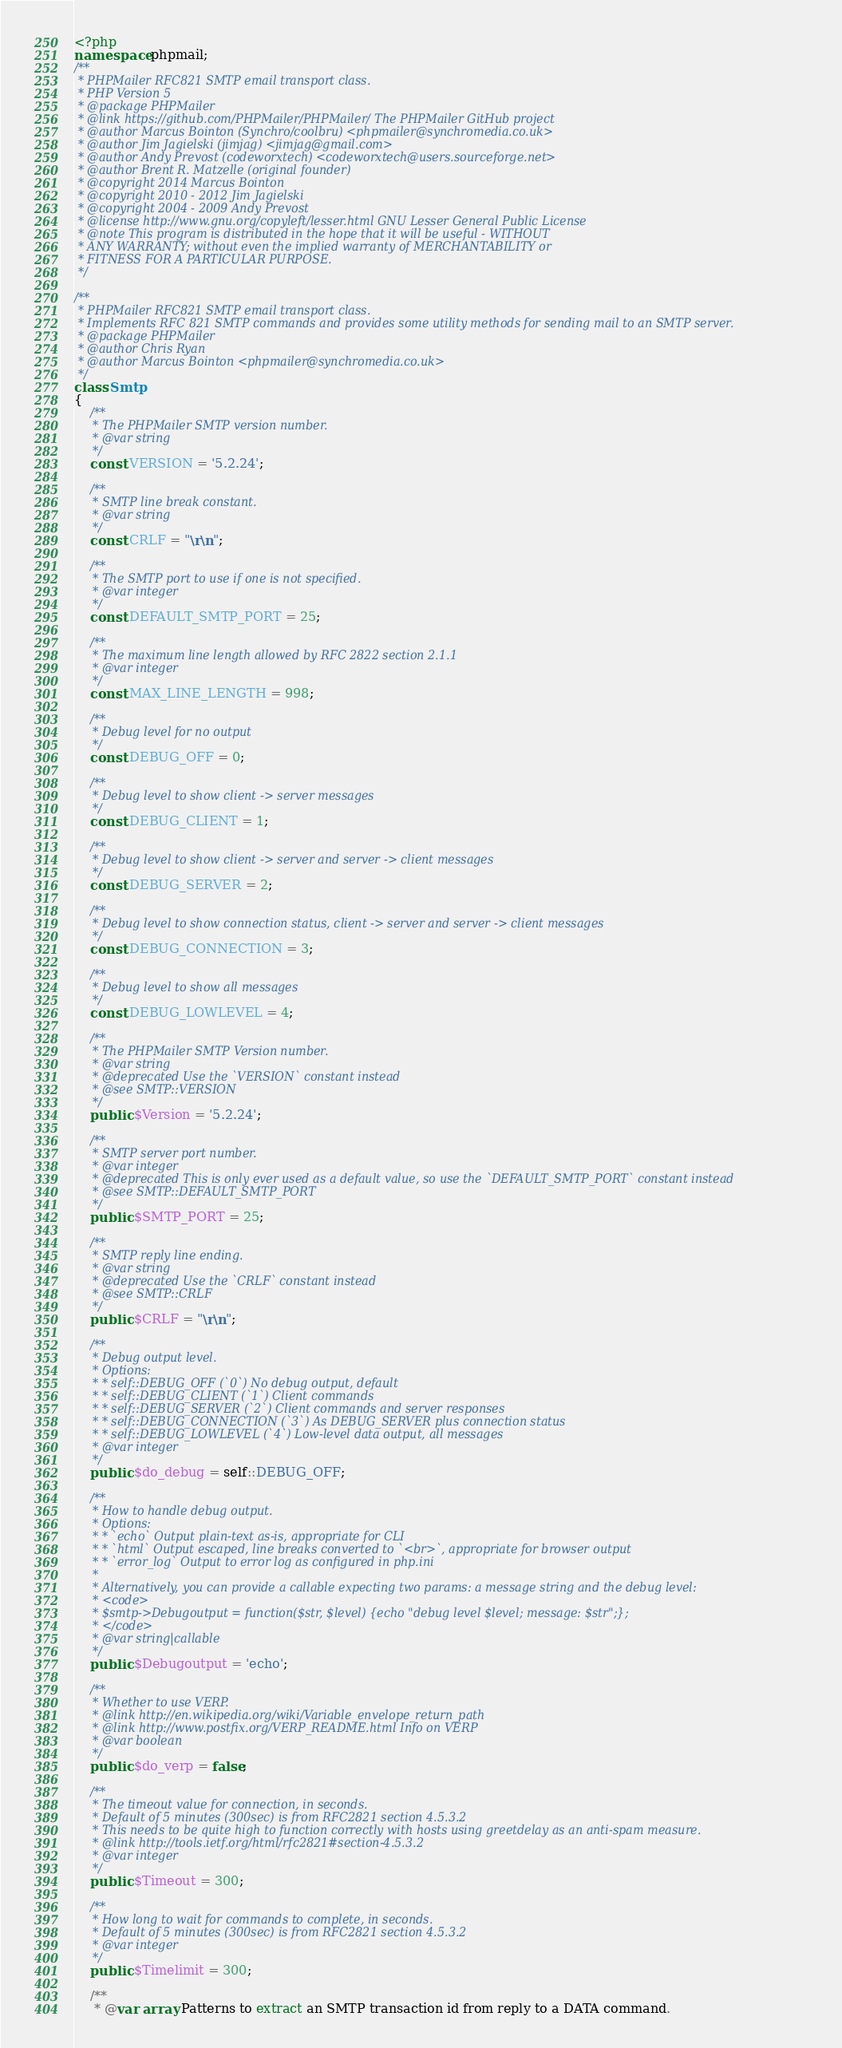Convert code to text. <code><loc_0><loc_0><loc_500><loc_500><_PHP_><?php
namespace phpmail;
/**
 * PHPMailer RFC821 SMTP email transport class.
 * PHP Version 5
 * @package PHPMailer
 * @link https://github.com/PHPMailer/PHPMailer/ The PHPMailer GitHub project
 * @author Marcus Bointon (Synchro/coolbru) <phpmailer@synchromedia.co.uk>
 * @author Jim Jagielski (jimjag) <jimjag@gmail.com>
 * @author Andy Prevost (codeworxtech) <codeworxtech@users.sourceforge.net>
 * @author Brent R. Matzelle (original founder)
 * @copyright 2014 Marcus Bointon
 * @copyright 2010 - 2012 Jim Jagielski
 * @copyright 2004 - 2009 Andy Prevost
 * @license http://www.gnu.org/copyleft/lesser.html GNU Lesser General Public License
 * @note This program is distributed in the hope that it will be useful - WITHOUT
 * ANY WARRANTY; without even the implied warranty of MERCHANTABILITY or
 * FITNESS FOR A PARTICULAR PURPOSE.
 */

/**
 * PHPMailer RFC821 SMTP email transport class.
 * Implements RFC 821 SMTP commands and provides some utility methods for sending mail to an SMTP server.
 * @package PHPMailer
 * @author Chris Ryan
 * @author Marcus Bointon <phpmailer@synchromedia.co.uk>
 */
class Smtp
{
    /**
     * The PHPMailer SMTP version number.
     * @var string
     */
    const VERSION = '5.2.24';

    /**
     * SMTP line break constant.
     * @var string
     */
    const CRLF = "\r\n";

    /**
     * The SMTP port to use if one is not specified.
     * @var integer
     */
    const DEFAULT_SMTP_PORT = 25;

    /**
     * The maximum line length allowed by RFC 2822 section 2.1.1
     * @var integer
     */
    const MAX_LINE_LENGTH = 998;

    /**
     * Debug level for no output
     */
    const DEBUG_OFF = 0;

    /**
     * Debug level to show client -> server messages
     */
    const DEBUG_CLIENT = 1;

    /**
     * Debug level to show client -> server and server -> client messages
     */
    const DEBUG_SERVER = 2;

    /**
     * Debug level to show connection status, client -> server and server -> client messages
     */
    const DEBUG_CONNECTION = 3;

    /**
     * Debug level to show all messages
     */
    const DEBUG_LOWLEVEL = 4;

    /**
     * The PHPMailer SMTP Version number.
     * @var string
     * @deprecated Use the `VERSION` constant instead
     * @see SMTP::VERSION
     */
    public $Version = '5.2.24';

    /**
     * SMTP server port number.
     * @var integer
     * @deprecated This is only ever used as a default value, so use the `DEFAULT_SMTP_PORT` constant instead
     * @see SMTP::DEFAULT_SMTP_PORT
     */
    public $SMTP_PORT = 25;

    /**
     * SMTP reply line ending.
     * @var string
     * @deprecated Use the `CRLF` constant instead
     * @see SMTP::CRLF
     */
    public $CRLF = "\r\n";

    /**
     * Debug output level.
     * Options:
     * * self::DEBUG_OFF (`0`) No debug output, default
     * * self::DEBUG_CLIENT (`1`) Client commands
     * * self::DEBUG_SERVER (`2`) Client commands and server responses
     * * self::DEBUG_CONNECTION (`3`) As DEBUG_SERVER plus connection status
     * * self::DEBUG_LOWLEVEL (`4`) Low-level data output, all messages
     * @var integer
     */
    public $do_debug = self::DEBUG_OFF;

    /**
     * How to handle debug output.
     * Options:
     * * `echo` Output plain-text as-is, appropriate for CLI
     * * `html` Output escaped, line breaks converted to `<br>`, appropriate for browser output
     * * `error_log` Output to error log as configured in php.ini
     *
     * Alternatively, you can provide a callable expecting two params: a message string and the debug level:
     * <code>
     * $smtp->Debugoutput = function($str, $level) {echo "debug level $level; message: $str";};
     * </code>
     * @var string|callable
     */
    public $Debugoutput = 'echo';

    /**
     * Whether to use VERP.
     * @link http://en.wikipedia.org/wiki/Variable_envelope_return_path
     * @link http://www.postfix.org/VERP_README.html Info on VERP
     * @var boolean
     */
    public $do_verp = false;

    /**
     * The timeout value for connection, in seconds.
     * Default of 5 minutes (300sec) is from RFC2821 section 4.5.3.2
     * This needs to be quite high to function correctly with hosts using greetdelay as an anti-spam measure.
     * @link http://tools.ietf.org/html/rfc2821#section-4.5.3.2
     * @var integer
     */
    public $Timeout = 300;

    /**
     * How long to wait for commands to complete, in seconds.
     * Default of 5 minutes (300sec) is from RFC2821 section 4.5.3.2
     * @var integer
     */
    public $Timelimit = 300;

    /**
     * @var array Patterns to extract an SMTP transaction id from reply to a DATA command.</code> 